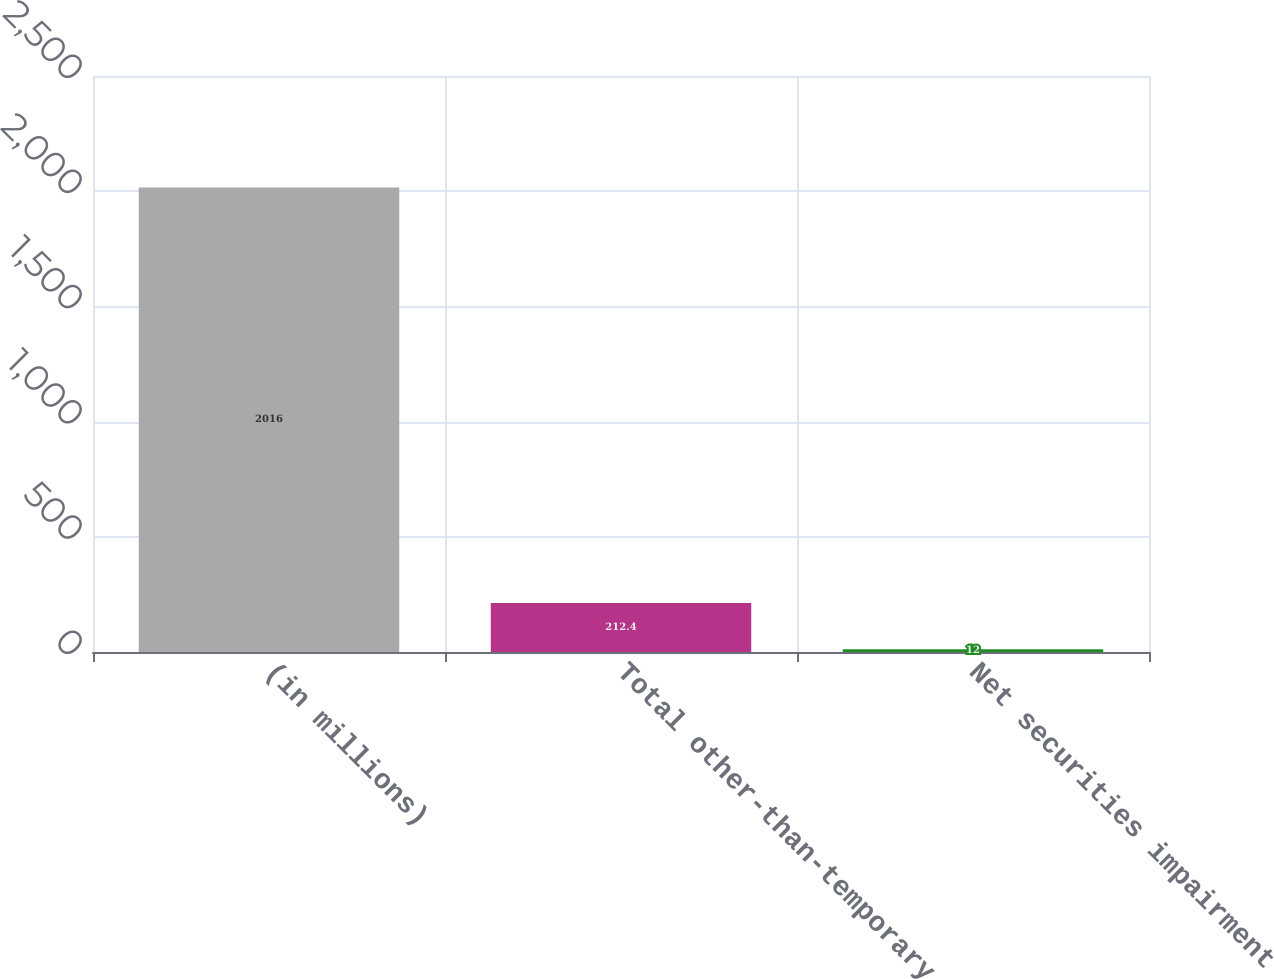<chart> <loc_0><loc_0><loc_500><loc_500><bar_chart><fcel>(in millions)<fcel>Total other-than-temporary<fcel>Net securities impairment<nl><fcel>2016<fcel>212.4<fcel>12<nl></chart> 